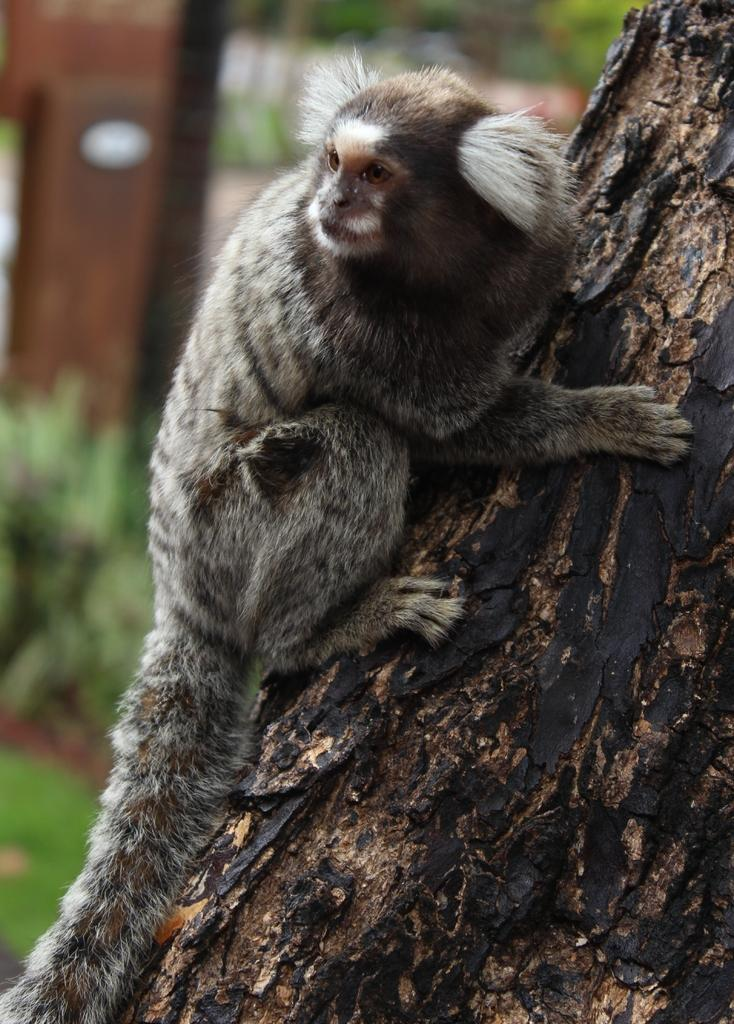What type of animal is in the image? There is a marmoset in the image. What is the marmoset holding? The marmoset is holding a tree. What can be seen at the bottom of the image? There are plants at the bottom of the image. How would you describe the background of the image? The background of the image appears blurry. What type of sand can be seen in the image? There is no sand present in the image. What color is the ink used to draw the marmoset? The image is a photograph, not a drawing, so there is no ink used. 